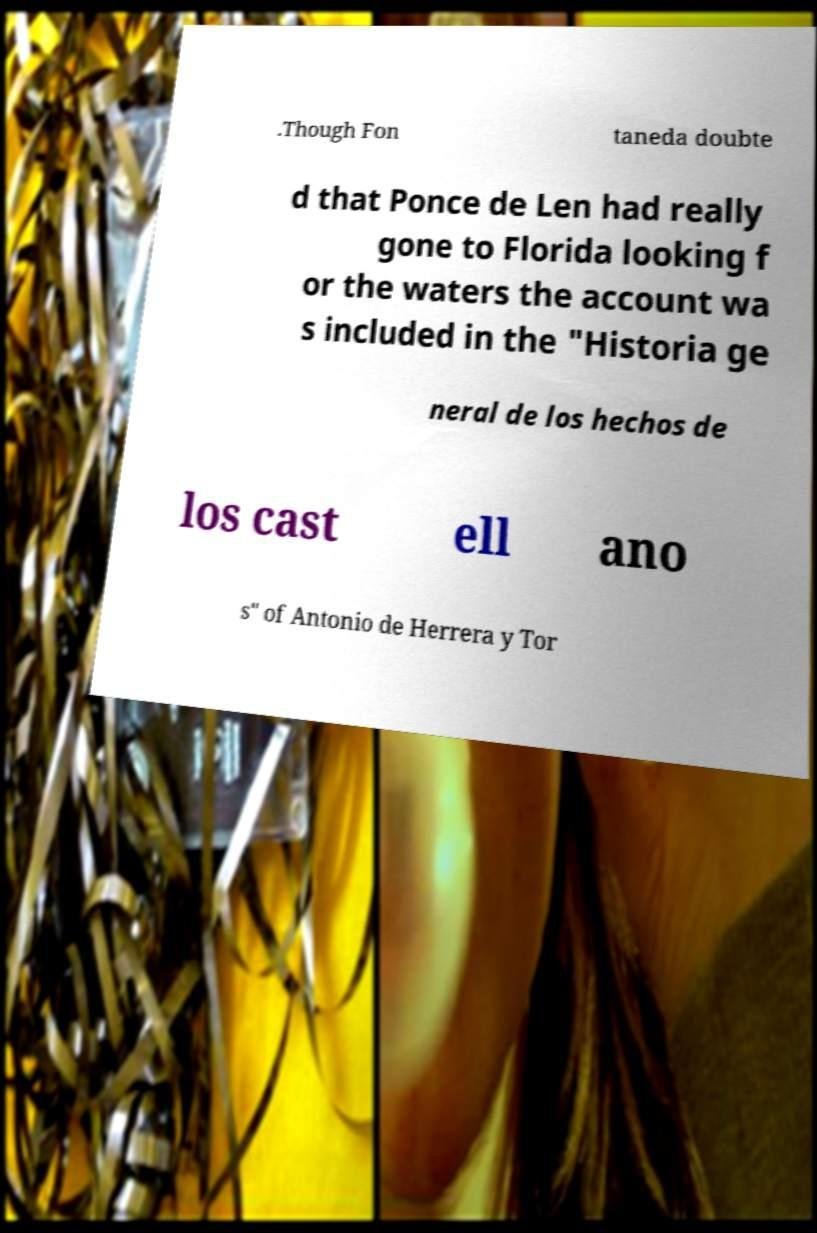Please identify and transcribe the text found in this image. .Though Fon taneda doubte d that Ponce de Len had really gone to Florida looking f or the waters the account wa s included in the "Historia ge neral de los hechos de los cast ell ano s" of Antonio de Herrera y Tor 